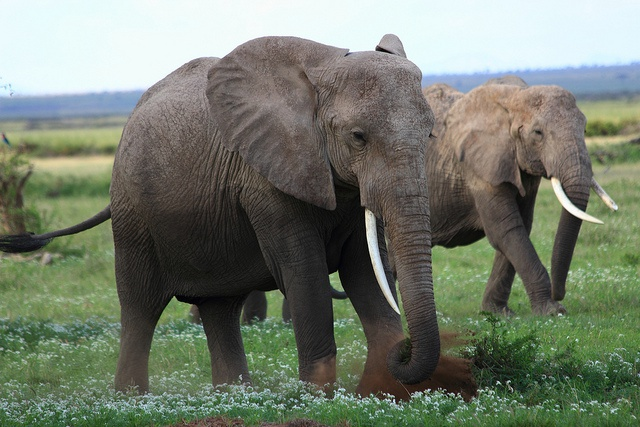Describe the objects in this image and their specific colors. I can see elephant in white, black, gray, and darkgray tones and elephant in white, gray, black, and darkgray tones in this image. 